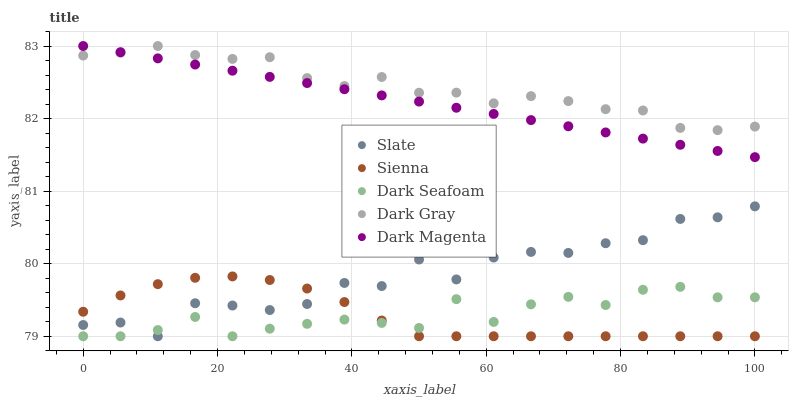Does Sienna have the minimum area under the curve?
Answer yes or no. Yes. Does Dark Gray have the maximum area under the curve?
Answer yes or no. Yes. Does Slate have the minimum area under the curve?
Answer yes or no. No. Does Slate have the maximum area under the curve?
Answer yes or no. No. Is Dark Magenta the smoothest?
Answer yes or no. Yes. Is Slate the roughest?
Answer yes or no. Yes. Is Dark Gray the smoothest?
Answer yes or no. No. Is Dark Gray the roughest?
Answer yes or no. No. Does Sienna have the lowest value?
Answer yes or no. Yes. Does Dark Gray have the lowest value?
Answer yes or no. No. Does Dark Magenta have the highest value?
Answer yes or no. Yes. Does Slate have the highest value?
Answer yes or no. No. Is Dark Seafoam less than Dark Gray?
Answer yes or no. Yes. Is Dark Magenta greater than Sienna?
Answer yes or no. Yes. Does Dark Seafoam intersect Sienna?
Answer yes or no. Yes. Is Dark Seafoam less than Sienna?
Answer yes or no. No. Is Dark Seafoam greater than Sienna?
Answer yes or no. No. Does Dark Seafoam intersect Dark Gray?
Answer yes or no. No. 